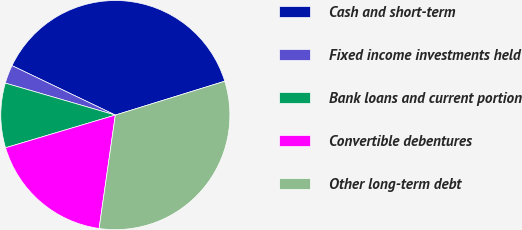Convert chart to OTSL. <chart><loc_0><loc_0><loc_500><loc_500><pie_chart><fcel>Cash and short-term<fcel>Fixed income investments held<fcel>Bank loans and current portion<fcel>Convertible debentures<fcel>Other long-term debt<nl><fcel>38.12%<fcel>2.6%<fcel>9.11%<fcel>18.13%<fcel>32.04%<nl></chart> 